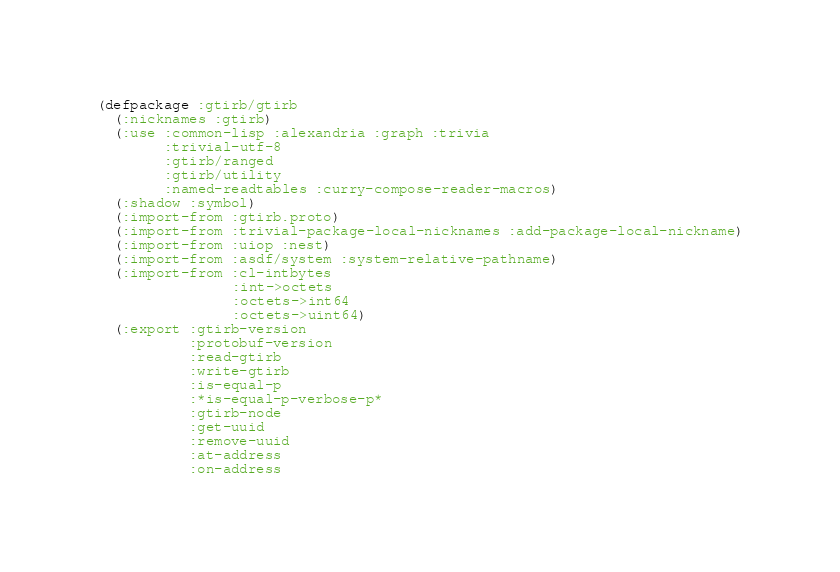<code> <loc_0><loc_0><loc_500><loc_500><_Lisp_>(defpackage :gtirb/gtirb
  (:nicknames :gtirb)
  (:use :common-lisp :alexandria :graph :trivia
        :trivial-utf-8
        :gtirb/ranged
        :gtirb/utility
        :named-readtables :curry-compose-reader-macros)
  (:shadow :symbol)
  (:import-from :gtirb.proto)
  (:import-from :trivial-package-local-nicknames :add-package-local-nickname)
  (:import-from :uiop :nest)
  (:import-from :asdf/system :system-relative-pathname)
  (:import-from :cl-intbytes
                :int->octets
                :octets->int64
                :octets->uint64)
  (:export :gtirb-version
           :protobuf-version
           :read-gtirb
           :write-gtirb
           :is-equal-p
           :*is-equal-p-verbose-p*
           :gtirb-node
           :get-uuid
           :remove-uuid
           :at-address
           :on-address</code> 